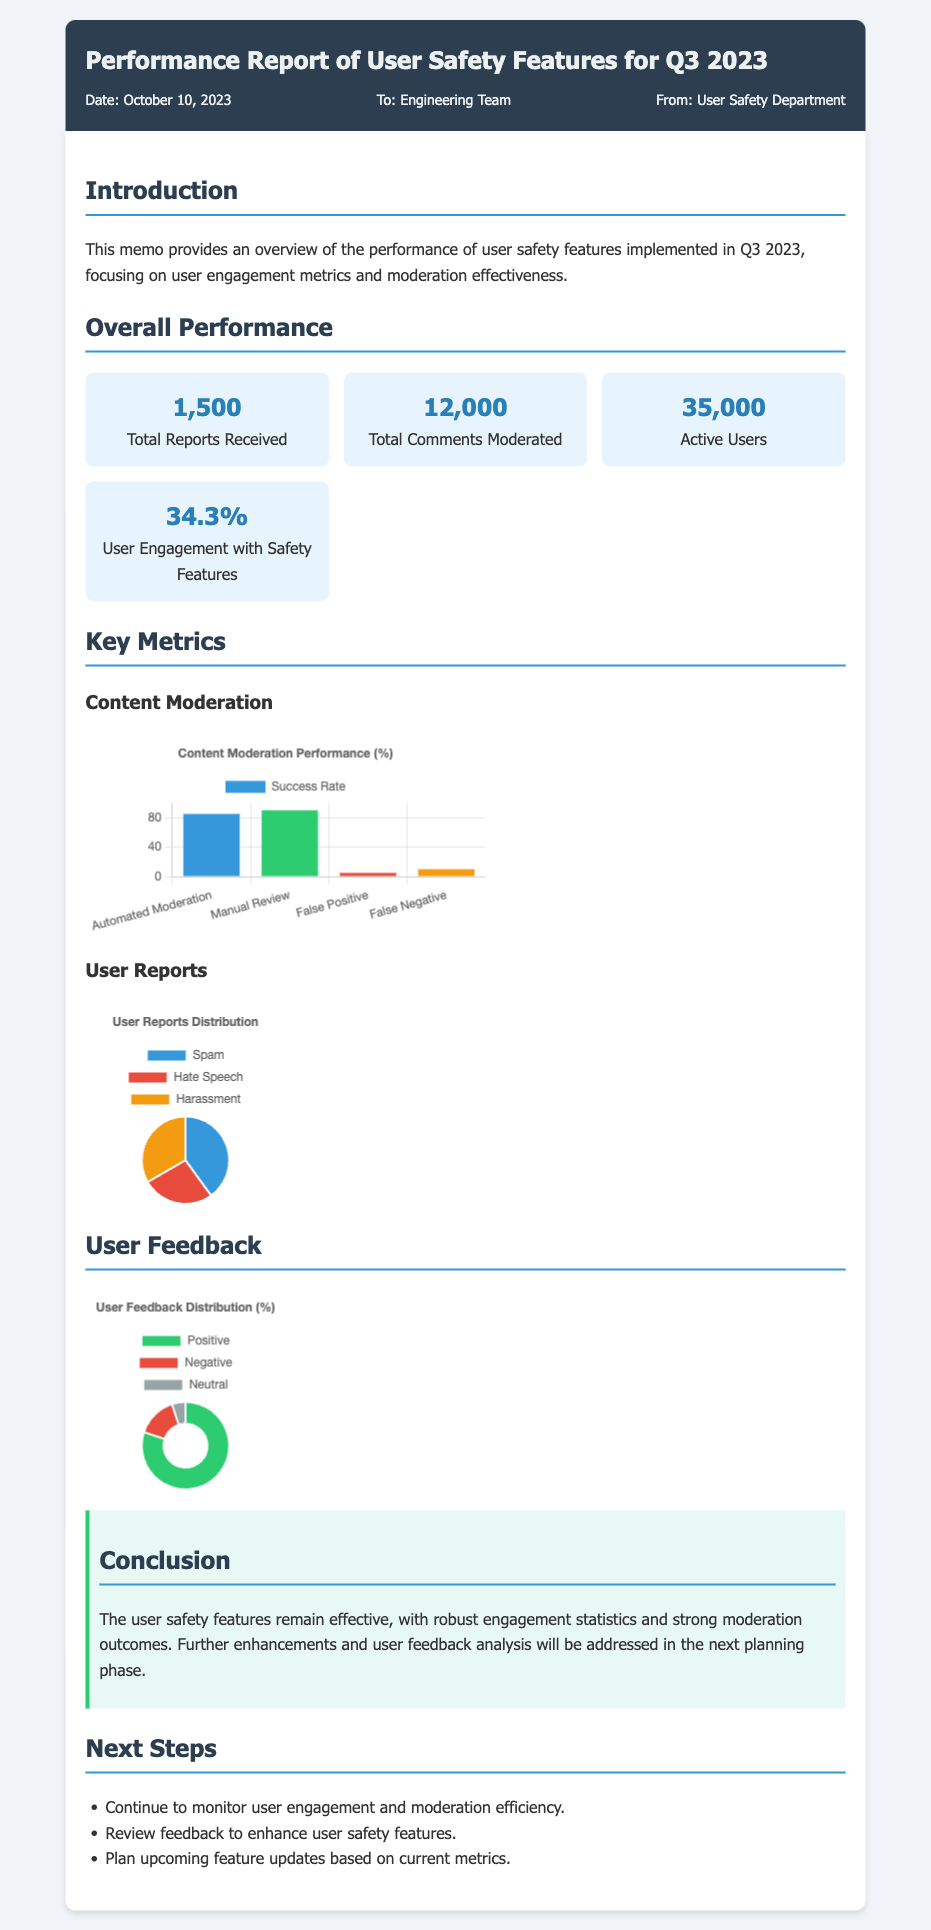What is the total number of reports received? The total number of reports received is explicitly stated in the document, which is 1,500.
Answer: 1,500 What percentage of user engagement with safety features was reported? The document provides the user engagement percentage, which is 34.3%.
Answer: 34.3% How many active users were there during Q3 2023? The document specifies that there were 35,000 active users.
Answer: 35,000 What was the success rate of automated moderation? The document states the success rate for automated moderation as 85%.
Answer: 85% What type of user report received the highest count? The reports distribution indicates that the highest count of user reports is for spam, with 600 reports.
Answer: Spam What is the total number of comments moderated? The document mentions that 12,000 comments were moderated.
Answer: 12,000 What is the primary conclusion stated in the memo? The conclusion summarizes the overall effectiveness of user safety features being robust.
Answer: Effective What are the next steps mentioned in the memo? The next steps include monitoring engagement and reviewing feedback for enhancements.
Answer: Monitoring engagement and reviewing feedback What is the primary focus of the memo? The memo primarily focuses on performance metrics regarding user safety features.
Answer: Performance metrics 